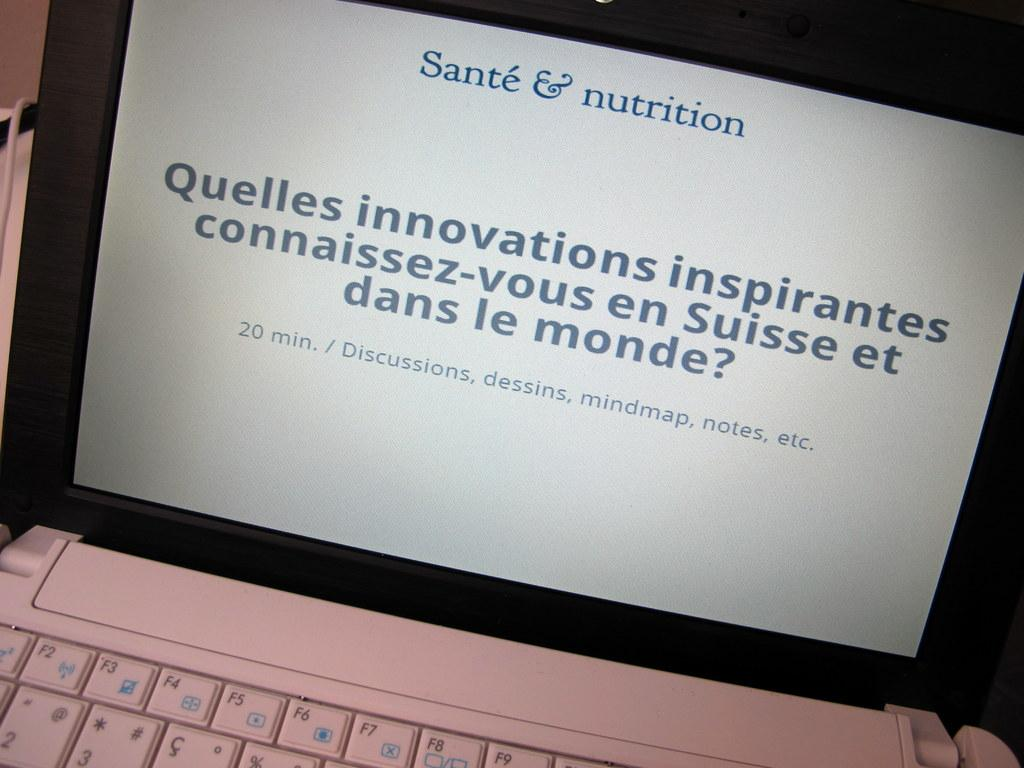<image>
Render a clear and concise summary of the photo. A laptop screen says Sante & nutrition at the top and 20 min/ Discussions at the bottom. 